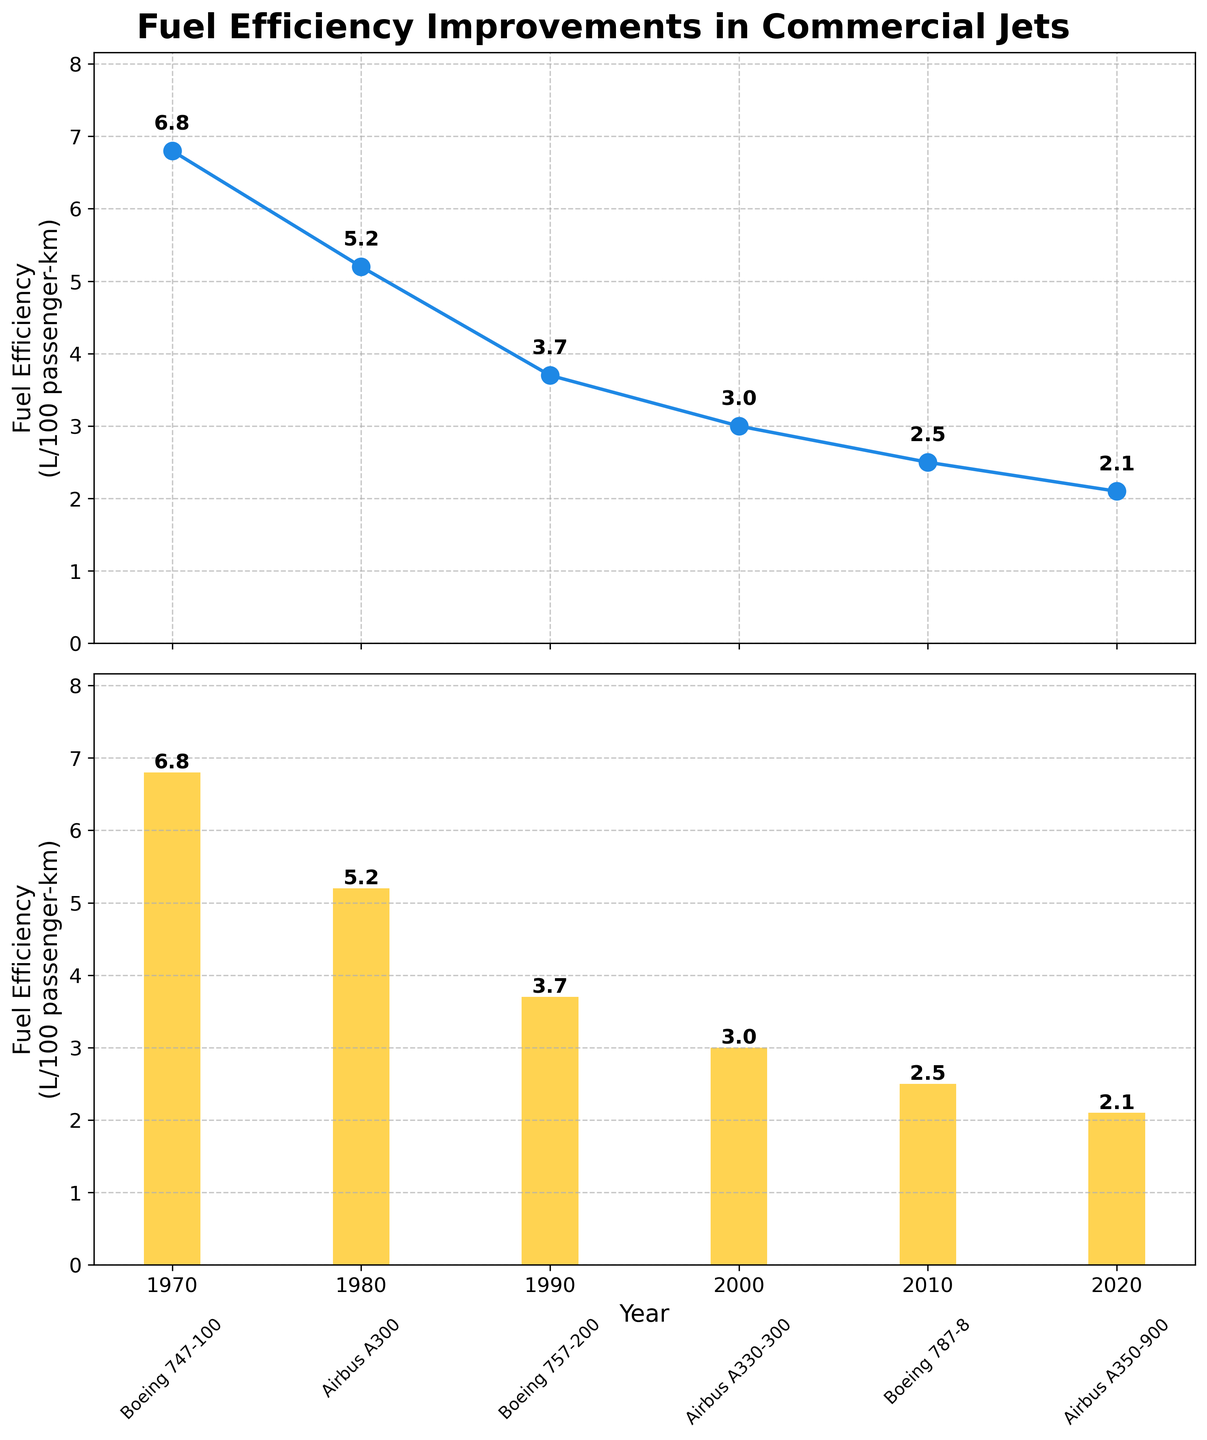Which aircraft model had the lowest fuel efficiency in the dataset? From the line plot, we can see that the highest value on the vertical axis corresponds to the Boeing 747-100 in 1970, which had a fuel efficiency of 6.8 L/100 passenger-km.
Answer: Boeing 747-100 What is the range of fuel efficiency values shown in the figure from the lowest to the highest? By looking at the lowest fuel efficiency value (2.1 L/100 passenger-km) and the highest fuel efficiency value (6.8 L/100 passenger-km), we find the range is 6.8 - 2.1 = 4.7 L/100 passenger-km.
Answer: 4.7 L/100 passenger-km How many aircraft models are plotted in the figure? By counting the number of markers or bars in either subplot, we can see there are six distinct aircraft models plotted.
Answer: 6 Which year had the greatest improvement in fuel efficiency compared to the previous decade? Compare differences between each decade: (1970-1980: 6.8 - 5.2 = 1.6), (1980-1990: 5.2 - 3.7 = 1.5), (1990-2000: 3.7 - 3.0 = 0.7), (2000-2010: 3.0 - 2.5 = 0.5), (2010-2020: 2.5 - 2.1 = 0.4). The greatest improvement was from 1970 to 1980.
Answer: 1970-1980 What's the average fuel efficiency of all the aircraft models shown? Sum all fuel efficiency values (6.8 + 5.2 + 3.7 + 3.0 + 2.5 + 2.1) = 23.3. Divide this sum by the total number of aircraft models, which is 6. This gives 23.3 / 6 = 3.88 L/100 passenger-km.
Answer: 3.88 L/100 passenger-km Compare the fuel efficiency of Boeing 787-8 and Airbus A350-900. Which is more fuel-efficient? From the plots, the Boeing 787-8 has a fuel efficiency of 2.5 L/100 passenger-km, while the Airbus A350-900 has a fuel efficiency of 2.1 L/100 passenger-km. Since 2.1 is less than 2.5, the Airbus A350-900 is more fuel-efficient.
Answer: Airbus A350-900 What trend do you observe in fuel efficiency over the years? Observing the figure, the trend shows a decrease in fuel efficiency values over the years, indicating that newer aircraft models have become increasingly fuel-efficient.
Answer: Increasing fuel efficiency 